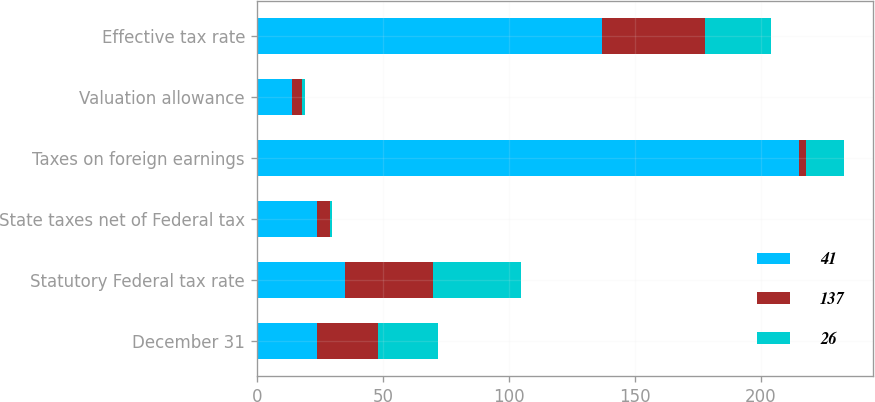Convert chart. <chart><loc_0><loc_0><loc_500><loc_500><stacked_bar_chart><ecel><fcel>December 31<fcel>Statutory Federal tax rate<fcel>State taxes net of Federal tax<fcel>Taxes on foreign earnings<fcel>Valuation allowance<fcel>Effective tax rate<nl><fcel>41<fcel>24<fcel>35<fcel>24<fcel>215<fcel>14<fcel>137<nl><fcel>137<fcel>24<fcel>35<fcel>5<fcel>3<fcel>4<fcel>41<nl><fcel>26<fcel>24<fcel>35<fcel>1<fcel>15<fcel>1<fcel>26<nl></chart> 